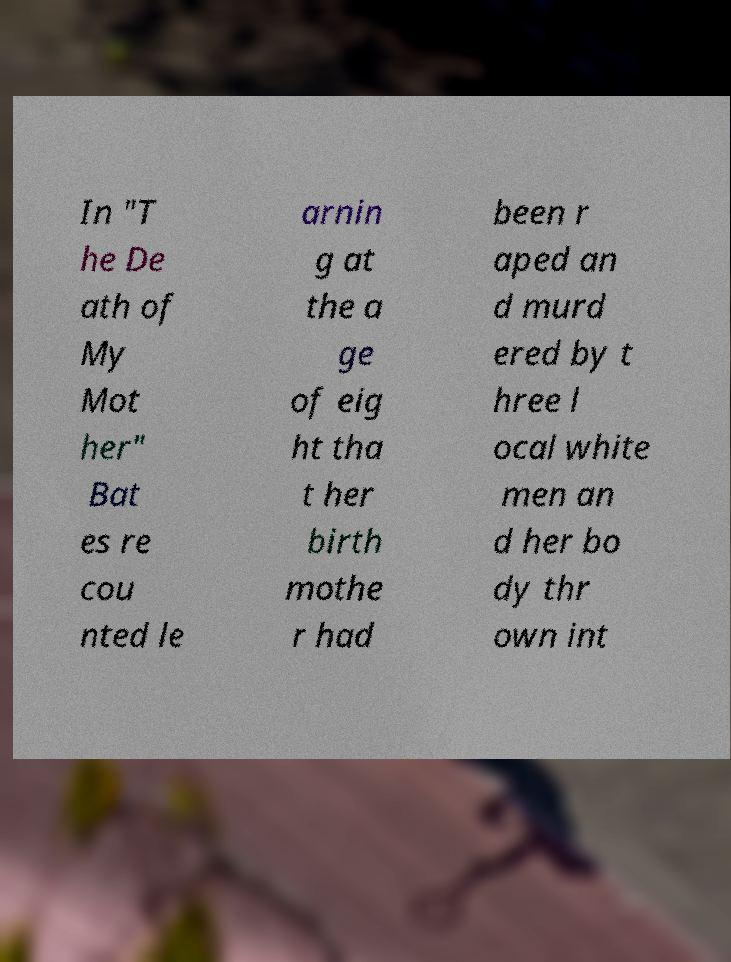Please identify and transcribe the text found in this image. In "T he De ath of My Mot her" Bat es re cou nted le arnin g at the a ge of eig ht tha t her birth mothe r had been r aped an d murd ered by t hree l ocal white men an d her bo dy thr own int 